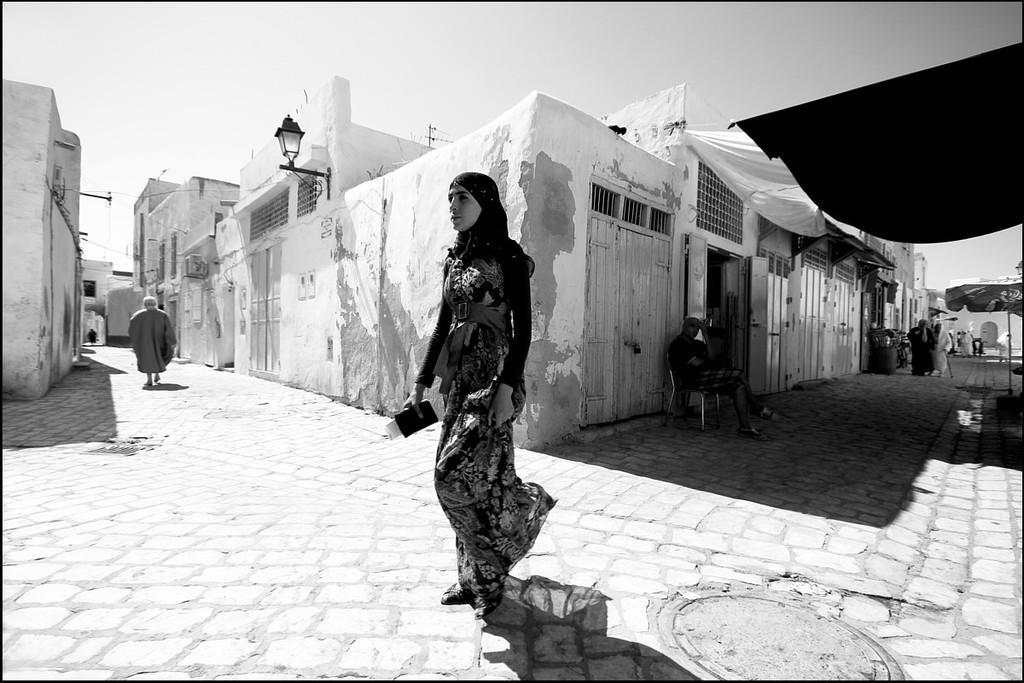Could you give a brief overview of what you see in this image? In this picture we can see a woman walking on the ground and in the background we can see buildings,people,sky. 